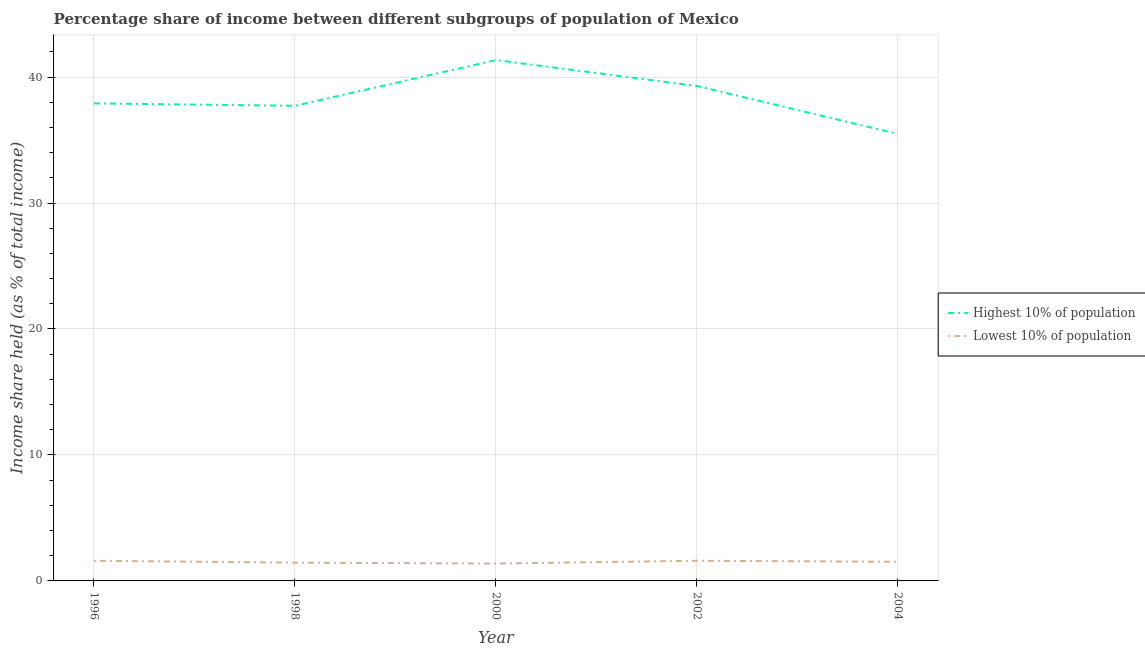How many different coloured lines are there?
Provide a short and direct response. 2. Does the line corresponding to income share held by lowest 10% of the population intersect with the line corresponding to income share held by highest 10% of the population?
Provide a succinct answer. No. Is the number of lines equal to the number of legend labels?
Your answer should be compact. Yes. What is the income share held by highest 10% of the population in 2002?
Your response must be concise. 39.29. Across all years, what is the maximum income share held by highest 10% of the population?
Keep it short and to the point. 41.35. Across all years, what is the minimum income share held by lowest 10% of the population?
Offer a terse response. 1.38. In which year was the income share held by lowest 10% of the population minimum?
Your answer should be very brief. 2000. What is the total income share held by highest 10% of the population in the graph?
Your response must be concise. 191.75. What is the difference between the income share held by highest 10% of the population in 2000 and that in 2002?
Make the answer very short. 2.06. What is the difference between the income share held by lowest 10% of the population in 1998 and the income share held by highest 10% of the population in 2000?
Offer a terse response. -39.9. What is the average income share held by lowest 10% of the population per year?
Provide a succinct answer. 1.51. In the year 2004, what is the difference between the income share held by highest 10% of the population and income share held by lowest 10% of the population?
Keep it short and to the point. 33.96. What is the ratio of the income share held by highest 10% of the population in 1996 to that in 2000?
Provide a succinct answer. 0.92. Is the income share held by lowest 10% of the population in 1998 less than that in 2000?
Offer a very short reply. No. Is the difference between the income share held by lowest 10% of the population in 1998 and 2000 greater than the difference between the income share held by highest 10% of the population in 1998 and 2000?
Provide a short and direct response. Yes. What is the difference between the highest and the second highest income share held by lowest 10% of the population?
Make the answer very short. 0. What is the difference between the highest and the lowest income share held by lowest 10% of the population?
Your answer should be very brief. 0.22. Does the income share held by lowest 10% of the population monotonically increase over the years?
Your answer should be very brief. No. Is the income share held by lowest 10% of the population strictly greater than the income share held by highest 10% of the population over the years?
Give a very brief answer. No. Is the income share held by lowest 10% of the population strictly less than the income share held by highest 10% of the population over the years?
Ensure brevity in your answer.  Yes. How many lines are there?
Your answer should be compact. 2. Are the values on the major ticks of Y-axis written in scientific E-notation?
Make the answer very short. No. How are the legend labels stacked?
Ensure brevity in your answer.  Vertical. What is the title of the graph?
Ensure brevity in your answer.  Percentage share of income between different subgroups of population of Mexico. What is the label or title of the Y-axis?
Offer a terse response. Income share held (as % of total income). What is the Income share held (as % of total income) of Highest 10% of population in 1996?
Keep it short and to the point. 37.91. What is the Income share held (as % of total income) of Lowest 10% of population in 1996?
Give a very brief answer. 1.6. What is the Income share held (as % of total income) of Highest 10% of population in 1998?
Give a very brief answer. 37.72. What is the Income share held (as % of total income) in Lowest 10% of population in 1998?
Provide a succinct answer. 1.45. What is the Income share held (as % of total income) of Highest 10% of population in 2000?
Provide a succinct answer. 41.35. What is the Income share held (as % of total income) in Lowest 10% of population in 2000?
Your response must be concise. 1.38. What is the Income share held (as % of total income) in Highest 10% of population in 2002?
Keep it short and to the point. 39.29. What is the Income share held (as % of total income) of Highest 10% of population in 2004?
Your response must be concise. 35.48. What is the Income share held (as % of total income) of Lowest 10% of population in 2004?
Your answer should be compact. 1.52. Across all years, what is the maximum Income share held (as % of total income) of Highest 10% of population?
Provide a short and direct response. 41.35. Across all years, what is the minimum Income share held (as % of total income) in Highest 10% of population?
Your answer should be compact. 35.48. Across all years, what is the minimum Income share held (as % of total income) of Lowest 10% of population?
Your answer should be compact. 1.38. What is the total Income share held (as % of total income) of Highest 10% of population in the graph?
Your answer should be compact. 191.75. What is the total Income share held (as % of total income) of Lowest 10% of population in the graph?
Provide a succinct answer. 7.55. What is the difference between the Income share held (as % of total income) in Highest 10% of population in 1996 and that in 1998?
Ensure brevity in your answer.  0.19. What is the difference between the Income share held (as % of total income) of Lowest 10% of population in 1996 and that in 1998?
Make the answer very short. 0.15. What is the difference between the Income share held (as % of total income) of Highest 10% of population in 1996 and that in 2000?
Ensure brevity in your answer.  -3.44. What is the difference between the Income share held (as % of total income) in Lowest 10% of population in 1996 and that in 2000?
Offer a very short reply. 0.22. What is the difference between the Income share held (as % of total income) of Highest 10% of population in 1996 and that in 2002?
Keep it short and to the point. -1.38. What is the difference between the Income share held (as % of total income) in Lowest 10% of population in 1996 and that in 2002?
Your answer should be very brief. 0. What is the difference between the Income share held (as % of total income) of Highest 10% of population in 1996 and that in 2004?
Offer a terse response. 2.43. What is the difference between the Income share held (as % of total income) in Lowest 10% of population in 1996 and that in 2004?
Your response must be concise. 0.08. What is the difference between the Income share held (as % of total income) of Highest 10% of population in 1998 and that in 2000?
Provide a short and direct response. -3.63. What is the difference between the Income share held (as % of total income) of Lowest 10% of population in 1998 and that in 2000?
Give a very brief answer. 0.07. What is the difference between the Income share held (as % of total income) in Highest 10% of population in 1998 and that in 2002?
Keep it short and to the point. -1.57. What is the difference between the Income share held (as % of total income) of Lowest 10% of population in 1998 and that in 2002?
Offer a terse response. -0.15. What is the difference between the Income share held (as % of total income) of Highest 10% of population in 1998 and that in 2004?
Your answer should be very brief. 2.24. What is the difference between the Income share held (as % of total income) of Lowest 10% of population in 1998 and that in 2004?
Your response must be concise. -0.07. What is the difference between the Income share held (as % of total income) of Highest 10% of population in 2000 and that in 2002?
Ensure brevity in your answer.  2.06. What is the difference between the Income share held (as % of total income) of Lowest 10% of population in 2000 and that in 2002?
Ensure brevity in your answer.  -0.22. What is the difference between the Income share held (as % of total income) in Highest 10% of population in 2000 and that in 2004?
Offer a very short reply. 5.87. What is the difference between the Income share held (as % of total income) of Lowest 10% of population in 2000 and that in 2004?
Ensure brevity in your answer.  -0.14. What is the difference between the Income share held (as % of total income) of Highest 10% of population in 2002 and that in 2004?
Your answer should be compact. 3.81. What is the difference between the Income share held (as % of total income) in Lowest 10% of population in 2002 and that in 2004?
Offer a very short reply. 0.08. What is the difference between the Income share held (as % of total income) of Highest 10% of population in 1996 and the Income share held (as % of total income) of Lowest 10% of population in 1998?
Offer a very short reply. 36.46. What is the difference between the Income share held (as % of total income) in Highest 10% of population in 1996 and the Income share held (as % of total income) in Lowest 10% of population in 2000?
Make the answer very short. 36.53. What is the difference between the Income share held (as % of total income) of Highest 10% of population in 1996 and the Income share held (as % of total income) of Lowest 10% of population in 2002?
Provide a succinct answer. 36.31. What is the difference between the Income share held (as % of total income) of Highest 10% of population in 1996 and the Income share held (as % of total income) of Lowest 10% of population in 2004?
Make the answer very short. 36.39. What is the difference between the Income share held (as % of total income) of Highest 10% of population in 1998 and the Income share held (as % of total income) of Lowest 10% of population in 2000?
Ensure brevity in your answer.  36.34. What is the difference between the Income share held (as % of total income) of Highest 10% of population in 1998 and the Income share held (as % of total income) of Lowest 10% of population in 2002?
Your answer should be very brief. 36.12. What is the difference between the Income share held (as % of total income) in Highest 10% of population in 1998 and the Income share held (as % of total income) in Lowest 10% of population in 2004?
Make the answer very short. 36.2. What is the difference between the Income share held (as % of total income) in Highest 10% of population in 2000 and the Income share held (as % of total income) in Lowest 10% of population in 2002?
Provide a short and direct response. 39.75. What is the difference between the Income share held (as % of total income) of Highest 10% of population in 2000 and the Income share held (as % of total income) of Lowest 10% of population in 2004?
Offer a very short reply. 39.83. What is the difference between the Income share held (as % of total income) of Highest 10% of population in 2002 and the Income share held (as % of total income) of Lowest 10% of population in 2004?
Your answer should be compact. 37.77. What is the average Income share held (as % of total income) in Highest 10% of population per year?
Ensure brevity in your answer.  38.35. What is the average Income share held (as % of total income) in Lowest 10% of population per year?
Offer a very short reply. 1.51. In the year 1996, what is the difference between the Income share held (as % of total income) of Highest 10% of population and Income share held (as % of total income) of Lowest 10% of population?
Offer a terse response. 36.31. In the year 1998, what is the difference between the Income share held (as % of total income) of Highest 10% of population and Income share held (as % of total income) of Lowest 10% of population?
Keep it short and to the point. 36.27. In the year 2000, what is the difference between the Income share held (as % of total income) in Highest 10% of population and Income share held (as % of total income) in Lowest 10% of population?
Keep it short and to the point. 39.97. In the year 2002, what is the difference between the Income share held (as % of total income) in Highest 10% of population and Income share held (as % of total income) in Lowest 10% of population?
Your answer should be compact. 37.69. In the year 2004, what is the difference between the Income share held (as % of total income) in Highest 10% of population and Income share held (as % of total income) in Lowest 10% of population?
Your response must be concise. 33.96. What is the ratio of the Income share held (as % of total income) of Highest 10% of population in 1996 to that in 1998?
Offer a terse response. 1. What is the ratio of the Income share held (as % of total income) of Lowest 10% of population in 1996 to that in 1998?
Provide a short and direct response. 1.1. What is the ratio of the Income share held (as % of total income) in Highest 10% of population in 1996 to that in 2000?
Give a very brief answer. 0.92. What is the ratio of the Income share held (as % of total income) of Lowest 10% of population in 1996 to that in 2000?
Your answer should be very brief. 1.16. What is the ratio of the Income share held (as % of total income) of Highest 10% of population in 1996 to that in 2002?
Your answer should be compact. 0.96. What is the ratio of the Income share held (as % of total income) in Highest 10% of population in 1996 to that in 2004?
Your answer should be very brief. 1.07. What is the ratio of the Income share held (as % of total income) in Lowest 10% of population in 1996 to that in 2004?
Provide a short and direct response. 1.05. What is the ratio of the Income share held (as % of total income) in Highest 10% of population in 1998 to that in 2000?
Give a very brief answer. 0.91. What is the ratio of the Income share held (as % of total income) of Lowest 10% of population in 1998 to that in 2000?
Your answer should be very brief. 1.05. What is the ratio of the Income share held (as % of total income) in Highest 10% of population in 1998 to that in 2002?
Your answer should be very brief. 0.96. What is the ratio of the Income share held (as % of total income) in Lowest 10% of population in 1998 to that in 2002?
Your answer should be compact. 0.91. What is the ratio of the Income share held (as % of total income) of Highest 10% of population in 1998 to that in 2004?
Give a very brief answer. 1.06. What is the ratio of the Income share held (as % of total income) of Lowest 10% of population in 1998 to that in 2004?
Make the answer very short. 0.95. What is the ratio of the Income share held (as % of total income) of Highest 10% of population in 2000 to that in 2002?
Offer a very short reply. 1.05. What is the ratio of the Income share held (as % of total income) in Lowest 10% of population in 2000 to that in 2002?
Offer a terse response. 0.86. What is the ratio of the Income share held (as % of total income) in Highest 10% of population in 2000 to that in 2004?
Your response must be concise. 1.17. What is the ratio of the Income share held (as % of total income) of Lowest 10% of population in 2000 to that in 2004?
Ensure brevity in your answer.  0.91. What is the ratio of the Income share held (as % of total income) in Highest 10% of population in 2002 to that in 2004?
Provide a succinct answer. 1.11. What is the ratio of the Income share held (as % of total income) of Lowest 10% of population in 2002 to that in 2004?
Provide a succinct answer. 1.05. What is the difference between the highest and the second highest Income share held (as % of total income) of Highest 10% of population?
Give a very brief answer. 2.06. What is the difference between the highest and the lowest Income share held (as % of total income) in Highest 10% of population?
Your answer should be very brief. 5.87. What is the difference between the highest and the lowest Income share held (as % of total income) in Lowest 10% of population?
Provide a short and direct response. 0.22. 